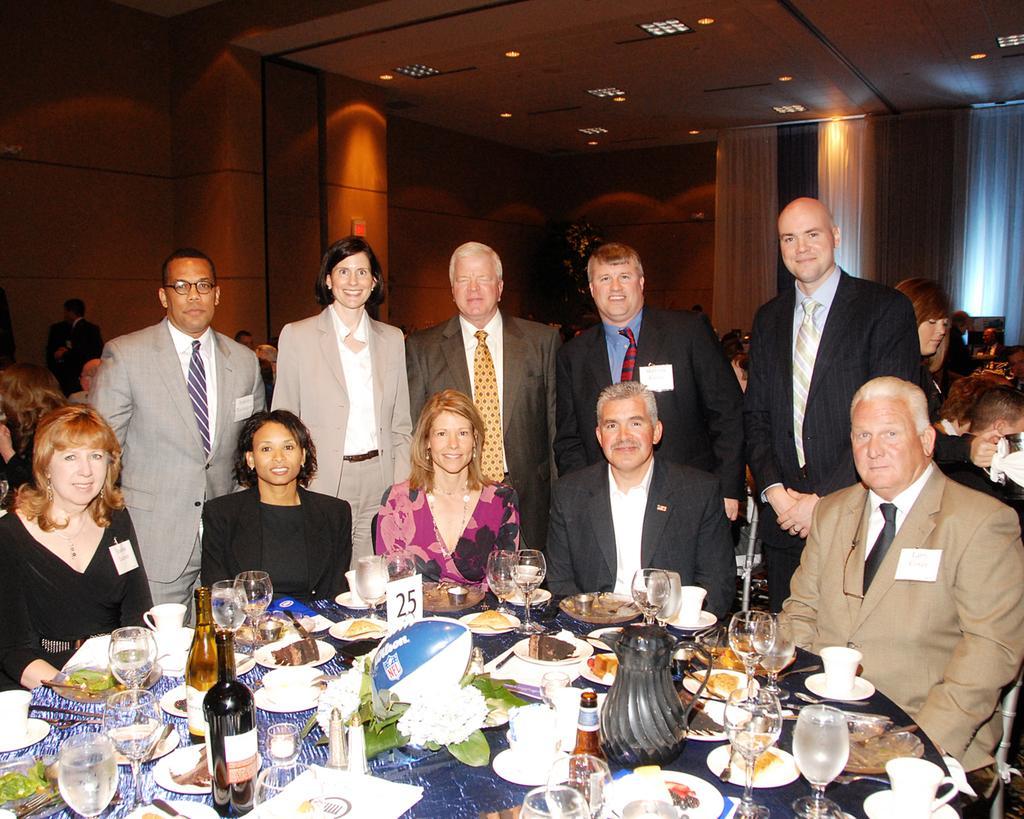Describe this image in one or two sentences. These five people sitting on chairs. Another five people are standing backside of these people. On this table there are bottles, glasses, cups and things. Background there are curtains and people. Lights are attached to the ceiling.  